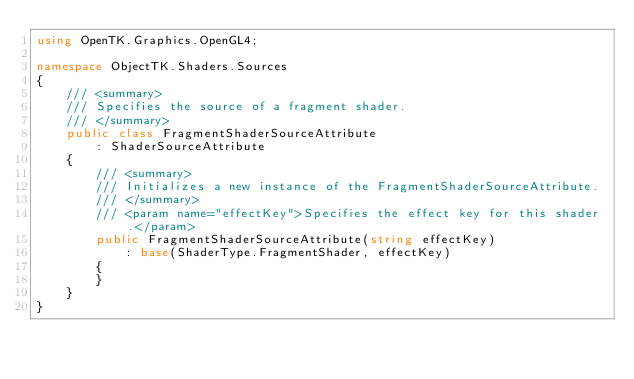Convert code to text. <code><loc_0><loc_0><loc_500><loc_500><_C#_>using OpenTK.Graphics.OpenGL4;

namespace ObjectTK.Shaders.Sources
{
    /// <summary>
    /// Specifies the source of a fragment shader.
    /// </summary>
    public class FragmentShaderSourceAttribute
        : ShaderSourceAttribute
    {
        /// <summary>
        /// Initializes a new instance of the FragmentShaderSourceAttribute.
        /// </summary>
        /// <param name="effectKey">Specifies the effect key for this shader.</param>
        public FragmentShaderSourceAttribute(string effectKey)
            : base(ShaderType.FragmentShader, effectKey)
        {
        }
    }
}</code> 